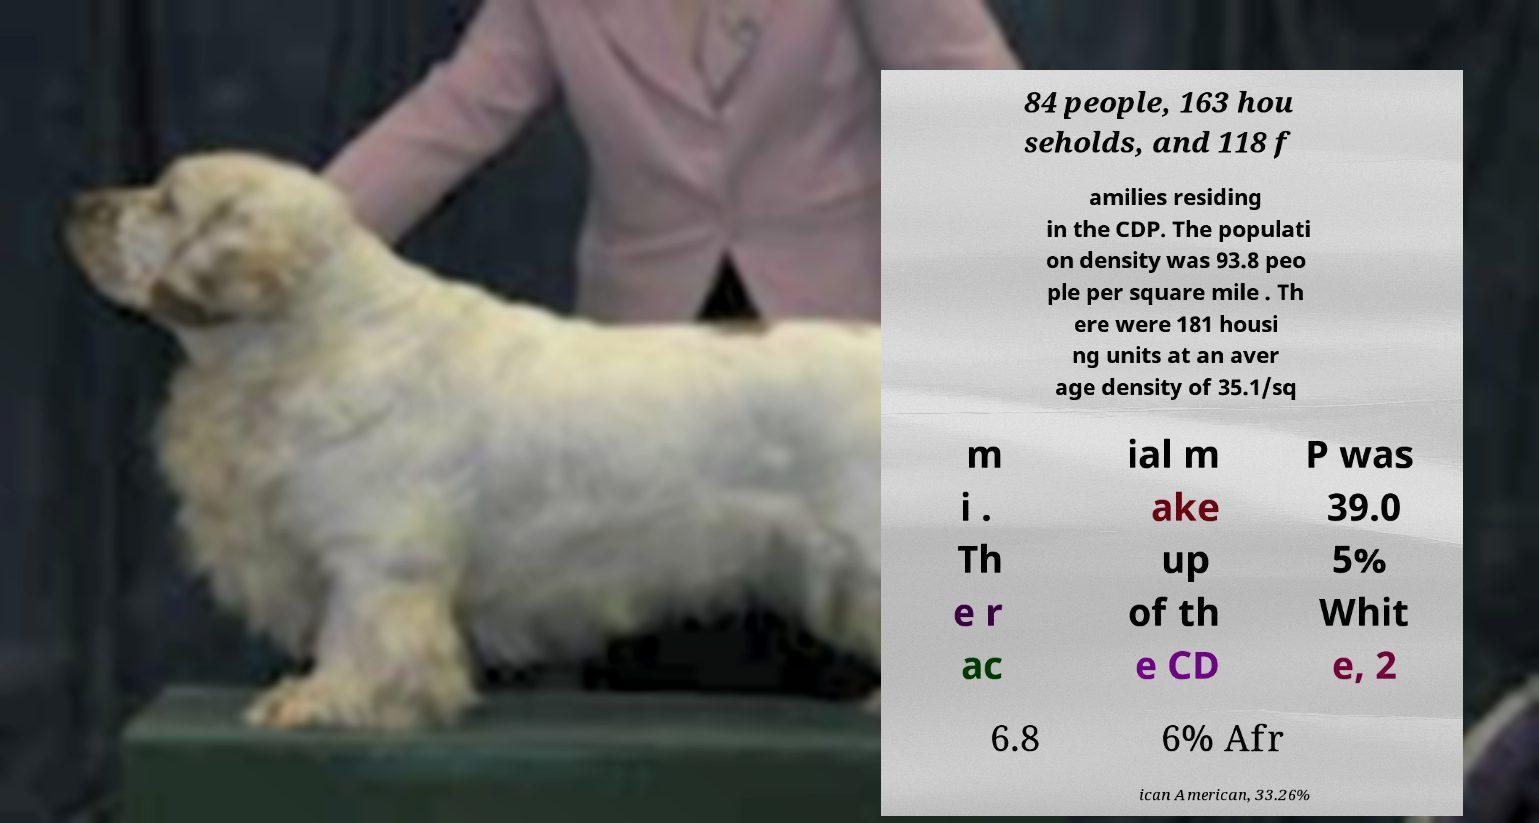Can you read and provide the text displayed in the image?This photo seems to have some interesting text. Can you extract and type it out for me? 84 people, 163 hou seholds, and 118 f amilies residing in the CDP. The populati on density was 93.8 peo ple per square mile . Th ere were 181 housi ng units at an aver age density of 35.1/sq m i . Th e r ac ial m ake up of th e CD P was 39.0 5% Whit e, 2 6.8 6% Afr ican American, 33.26% 